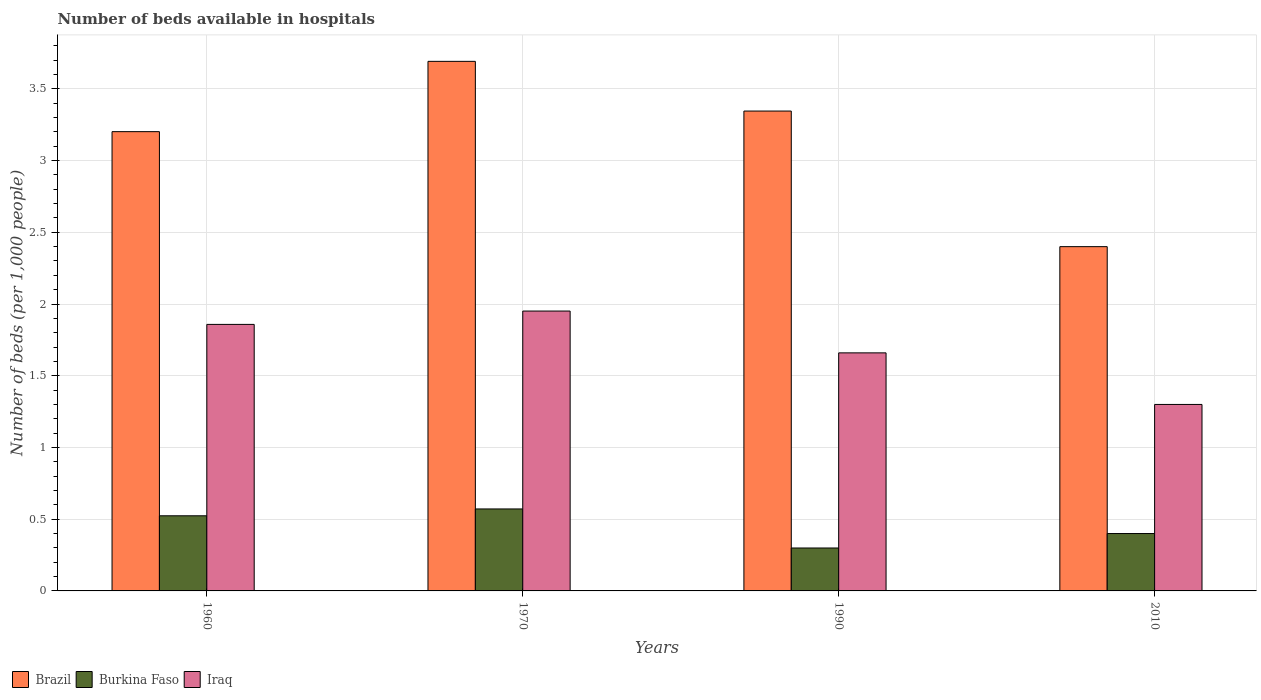How many different coloured bars are there?
Offer a very short reply. 3. How many groups of bars are there?
Provide a short and direct response. 4. Are the number of bars on each tick of the X-axis equal?
Keep it short and to the point. Yes. How many bars are there on the 1st tick from the right?
Your answer should be very brief. 3. Across all years, what is the maximum number of beds in the hospiatls of in Burkina Faso?
Keep it short and to the point. 0.57. In which year was the number of beds in the hospiatls of in Iraq maximum?
Your answer should be compact. 1970. In which year was the number of beds in the hospiatls of in Iraq minimum?
Make the answer very short. 2010. What is the total number of beds in the hospiatls of in Burkina Faso in the graph?
Offer a very short reply. 1.79. What is the difference between the number of beds in the hospiatls of in Brazil in 1970 and that in 1990?
Give a very brief answer. 0.35. What is the difference between the number of beds in the hospiatls of in Iraq in 1960 and the number of beds in the hospiatls of in Burkina Faso in 1990?
Make the answer very short. 1.56. What is the average number of beds in the hospiatls of in Burkina Faso per year?
Offer a terse response. 0.45. In the year 1960, what is the difference between the number of beds in the hospiatls of in Iraq and number of beds in the hospiatls of in Burkina Faso?
Your answer should be compact. 1.33. In how many years, is the number of beds in the hospiatls of in Iraq greater than 2.8?
Offer a terse response. 0. What is the ratio of the number of beds in the hospiatls of in Brazil in 1970 to that in 2010?
Give a very brief answer. 1.54. Is the number of beds in the hospiatls of in Burkina Faso in 1970 less than that in 2010?
Make the answer very short. No. Is the difference between the number of beds in the hospiatls of in Iraq in 1970 and 1990 greater than the difference between the number of beds in the hospiatls of in Burkina Faso in 1970 and 1990?
Your answer should be very brief. Yes. What is the difference between the highest and the second highest number of beds in the hospiatls of in Burkina Faso?
Keep it short and to the point. 0.05. What is the difference between the highest and the lowest number of beds in the hospiatls of in Burkina Faso?
Your answer should be compact. 0.27. In how many years, is the number of beds in the hospiatls of in Iraq greater than the average number of beds in the hospiatls of in Iraq taken over all years?
Keep it short and to the point. 2. Is the sum of the number of beds in the hospiatls of in Burkina Faso in 1960 and 1990 greater than the maximum number of beds in the hospiatls of in Brazil across all years?
Provide a short and direct response. No. What does the 2nd bar from the left in 2010 represents?
Provide a succinct answer. Burkina Faso. What does the 2nd bar from the right in 1970 represents?
Offer a terse response. Burkina Faso. Are all the bars in the graph horizontal?
Ensure brevity in your answer.  No. How many years are there in the graph?
Your answer should be very brief. 4. What is the difference between two consecutive major ticks on the Y-axis?
Your answer should be very brief. 0.5. Are the values on the major ticks of Y-axis written in scientific E-notation?
Your answer should be compact. No. Does the graph contain any zero values?
Your answer should be very brief. No. How are the legend labels stacked?
Provide a succinct answer. Horizontal. What is the title of the graph?
Provide a short and direct response. Number of beds available in hospitals. What is the label or title of the Y-axis?
Provide a short and direct response. Number of beds (per 1,0 people). What is the Number of beds (per 1,000 people) of Brazil in 1960?
Make the answer very short. 3.2. What is the Number of beds (per 1,000 people) of Burkina Faso in 1960?
Keep it short and to the point. 0.52. What is the Number of beds (per 1,000 people) of Iraq in 1960?
Offer a terse response. 1.86. What is the Number of beds (per 1,000 people) of Brazil in 1970?
Your answer should be compact. 3.69. What is the Number of beds (per 1,000 people) in Burkina Faso in 1970?
Your answer should be very brief. 0.57. What is the Number of beds (per 1,000 people) of Iraq in 1970?
Give a very brief answer. 1.95. What is the Number of beds (per 1,000 people) of Brazil in 1990?
Your answer should be very brief. 3.35. What is the Number of beds (per 1,000 people) in Burkina Faso in 1990?
Give a very brief answer. 0.3. What is the Number of beds (per 1,000 people) in Iraq in 1990?
Offer a terse response. 1.66. What is the Number of beds (per 1,000 people) in Iraq in 2010?
Give a very brief answer. 1.3. Across all years, what is the maximum Number of beds (per 1,000 people) of Brazil?
Your answer should be compact. 3.69. Across all years, what is the maximum Number of beds (per 1,000 people) in Burkina Faso?
Your answer should be very brief. 0.57. Across all years, what is the maximum Number of beds (per 1,000 people) of Iraq?
Offer a very short reply. 1.95. Across all years, what is the minimum Number of beds (per 1,000 people) in Brazil?
Your response must be concise. 2.4. Across all years, what is the minimum Number of beds (per 1,000 people) of Burkina Faso?
Make the answer very short. 0.3. What is the total Number of beds (per 1,000 people) in Brazil in the graph?
Keep it short and to the point. 12.64. What is the total Number of beds (per 1,000 people) in Burkina Faso in the graph?
Your answer should be compact. 1.79. What is the total Number of beds (per 1,000 people) of Iraq in the graph?
Your response must be concise. 6.77. What is the difference between the Number of beds (per 1,000 people) in Brazil in 1960 and that in 1970?
Offer a terse response. -0.49. What is the difference between the Number of beds (per 1,000 people) of Burkina Faso in 1960 and that in 1970?
Make the answer very short. -0.05. What is the difference between the Number of beds (per 1,000 people) in Iraq in 1960 and that in 1970?
Provide a succinct answer. -0.09. What is the difference between the Number of beds (per 1,000 people) in Brazil in 1960 and that in 1990?
Offer a terse response. -0.14. What is the difference between the Number of beds (per 1,000 people) in Burkina Faso in 1960 and that in 1990?
Ensure brevity in your answer.  0.22. What is the difference between the Number of beds (per 1,000 people) in Iraq in 1960 and that in 1990?
Provide a short and direct response. 0.2. What is the difference between the Number of beds (per 1,000 people) in Brazil in 1960 and that in 2010?
Your answer should be compact. 0.8. What is the difference between the Number of beds (per 1,000 people) of Burkina Faso in 1960 and that in 2010?
Give a very brief answer. 0.12. What is the difference between the Number of beds (per 1,000 people) of Iraq in 1960 and that in 2010?
Your response must be concise. 0.56. What is the difference between the Number of beds (per 1,000 people) of Brazil in 1970 and that in 1990?
Offer a terse response. 0.35. What is the difference between the Number of beds (per 1,000 people) in Burkina Faso in 1970 and that in 1990?
Your response must be concise. 0.27. What is the difference between the Number of beds (per 1,000 people) in Iraq in 1970 and that in 1990?
Make the answer very short. 0.29. What is the difference between the Number of beds (per 1,000 people) of Brazil in 1970 and that in 2010?
Offer a terse response. 1.29. What is the difference between the Number of beds (per 1,000 people) in Burkina Faso in 1970 and that in 2010?
Make the answer very short. 0.17. What is the difference between the Number of beds (per 1,000 people) in Iraq in 1970 and that in 2010?
Offer a terse response. 0.65. What is the difference between the Number of beds (per 1,000 people) in Brazil in 1990 and that in 2010?
Your answer should be very brief. 0.95. What is the difference between the Number of beds (per 1,000 people) of Burkina Faso in 1990 and that in 2010?
Ensure brevity in your answer.  -0.1. What is the difference between the Number of beds (per 1,000 people) of Iraq in 1990 and that in 2010?
Your answer should be very brief. 0.36. What is the difference between the Number of beds (per 1,000 people) in Brazil in 1960 and the Number of beds (per 1,000 people) in Burkina Faso in 1970?
Give a very brief answer. 2.63. What is the difference between the Number of beds (per 1,000 people) of Brazil in 1960 and the Number of beds (per 1,000 people) of Iraq in 1970?
Provide a succinct answer. 1.25. What is the difference between the Number of beds (per 1,000 people) of Burkina Faso in 1960 and the Number of beds (per 1,000 people) of Iraq in 1970?
Provide a short and direct response. -1.43. What is the difference between the Number of beds (per 1,000 people) in Brazil in 1960 and the Number of beds (per 1,000 people) in Burkina Faso in 1990?
Offer a very short reply. 2.9. What is the difference between the Number of beds (per 1,000 people) in Brazil in 1960 and the Number of beds (per 1,000 people) in Iraq in 1990?
Give a very brief answer. 1.54. What is the difference between the Number of beds (per 1,000 people) of Burkina Faso in 1960 and the Number of beds (per 1,000 people) of Iraq in 1990?
Your response must be concise. -1.14. What is the difference between the Number of beds (per 1,000 people) of Brazil in 1960 and the Number of beds (per 1,000 people) of Burkina Faso in 2010?
Offer a terse response. 2.8. What is the difference between the Number of beds (per 1,000 people) in Brazil in 1960 and the Number of beds (per 1,000 people) in Iraq in 2010?
Make the answer very short. 1.9. What is the difference between the Number of beds (per 1,000 people) in Burkina Faso in 1960 and the Number of beds (per 1,000 people) in Iraq in 2010?
Give a very brief answer. -0.78. What is the difference between the Number of beds (per 1,000 people) in Brazil in 1970 and the Number of beds (per 1,000 people) in Burkina Faso in 1990?
Make the answer very short. 3.39. What is the difference between the Number of beds (per 1,000 people) in Brazil in 1970 and the Number of beds (per 1,000 people) in Iraq in 1990?
Give a very brief answer. 2.03. What is the difference between the Number of beds (per 1,000 people) of Burkina Faso in 1970 and the Number of beds (per 1,000 people) of Iraq in 1990?
Offer a very short reply. -1.09. What is the difference between the Number of beds (per 1,000 people) of Brazil in 1970 and the Number of beds (per 1,000 people) of Burkina Faso in 2010?
Ensure brevity in your answer.  3.29. What is the difference between the Number of beds (per 1,000 people) in Brazil in 1970 and the Number of beds (per 1,000 people) in Iraq in 2010?
Your response must be concise. 2.39. What is the difference between the Number of beds (per 1,000 people) of Burkina Faso in 1970 and the Number of beds (per 1,000 people) of Iraq in 2010?
Your response must be concise. -0.73. What is the difference between the Number of beds (per 1,000 people) in Brazil in 1990 and the Number of beds (per 1,000 people) in Burkina Faso in 2010?
Your answer should be very brief. 2.95. What is the difference between the Number of beds (per 1,000 people) of Brazil in 1990 and the Number of beds (per 1,000 people) of Iraq in 2010?
Ensure brevity in your answer.  2.05. What is the difference between the Number of beds (per 1,000 people) in Burkina Faso in 1990 and the Number of beds (per 1,000 people) in Iraq in 2010?
Make the answer very short. -1. What is the average Number of beds (per 1,000 people) of Brazil per year?
Offer a very short reply. 3.16. What is the average Number of beds (per 1,000 people) of Burkina Faso per year?
Provide a short and direct response. 0.45. What is the average Number of beds (per 1,000 people) in Iraq per year?
Make the answer very short. 1.69. In the year 1960, what is the difference between the Number of beds (per 1,000 people) in Brazil and Number of beds (per 1,000 people) in Burkina Faso?
Your answer should be very brief. 2.68. In the year 1960, what is the difference between the Number of beds (per 1,000 people) of Brazil and Number of beds (per 1,000 people) of Iraq?
Provide a succinct answer. 1.34. In the year 1960, what is the difference between the Number of beds (per 1,000 people) in Burkina Faso and Number of beds (per 1,000 people) in Iraq?
Offer a terse response. -1.33. In the year 1970, what is the difference between the Number of beds (per 1,000 people) of Brazil and Number of beds (per 1,000 people) of Burkina Faso?
Make the answer very short. 3.12. In the year 1970, what is the difference between the Number of beds (per 1,000 people) of Brazil and Number of beds (per 1,000 people) of Iraq?
Make the answer very short. 1.74. In the year 1970, what is the difference between the Number of beds (per 1,000 people) of Burkina Faso and Number of beds (per 1,000 people) of Iraq?
Your answer should be compact. -1.38. In the year 1990, what is the difference between the Number of beds (per 1,000 people) of Brazil and Number of beds (per 1,000 people) of Burkina Faso?
Your answer should be compact. 3.05. In the year 1990, what is the difference between the Number of beds (per 1,000 people) in Brazil and Number of beds (per 1,000 people) in Iraq?
Your answer should be very brief. 1.69. In the year 1990, what is the difference between the Number of beds (per 1,000 people) of Burkina Faso and Number of beds (per 1,000 people) of Iraq?
Offer a terse response. -1.36. What is the ratio of the Number of beds (per 1,000 people) of Brazil in 1960 to that in 1970?
Your response must be concise. 0.87. What is the ratio of the Number of beds (per 1,000 people) of Burkina Faso in 1960 to that in 1970?
Ensure brevity in your answer.  0.92. What is the ratio of the Number of beds (per 1,000 people) of Iraq in 1960 to that in 1970?
Make the answer very short. 0.95. What is the ratio of the Number of beds (per 1,000 people) of Brazil in 1960 to that in 1990?
Keep it short and to the point. 0.96. What is the ratio of the Number of beds (per 1,000 people) in Burkina Faso in 1960 to that in 1990?
Offer a very short reply. 1.75. What is the ratio of the Number of beds (per 1,000 people) of Iraq in 1960 to that in 1990?
Ensure brevity in your answer.  1.12. What is the ratio of the Number of beds (per 1,000 people) of Brazil in 1960 to that in 2010?
Your response must be concise. 1.33. What is the ratio of the Number of beds (per 1,000 people) in Burkina Faso in 1960 to that in 2010?
Offer a terse response. 1.31. What is the ratio of the Number of beds (per 1,000 people) in Iraq in 1960 to that in 2010?
Provide a succinct answer. 1.43. What is the ratio of the Number of beds (per 1,000 people) of Brazil in 1970 to that in 1990?
Your response must be concise. 1.1. What is the ratio of the Number of beds (per 1,000 people) in Burkina Faso in 1970 to that in 1990?
Your response must be concise. 1.91. What is the ratio of the Number of beds (per 1,000 people) in Iraq in 1970 to that in 1990?
Provide a short and direct response. 1.18. What is the ratio of the Number of beds (per 1,000 people) in Brazil in 1970 to that in 2010?
Your answer should be very brief. 1.54. What is the ratio of the Number of beds (per 1,000 people) in Burkina Faso in 1970 to that in 2010?
Your answer should be very brief. 1.43. What is the ratio of the Number of beds (per 1,000 people) of Iraq in 1970 to that in 2010?
Provide a short and direct response. 1.5. What is the ratio of the Number of beds (per 1,000 people) of Brazil in 1990 to that in 2010?
Your answer should be compact. 1.39. What is the ratio of the Number of beds (per 1,000 people) in Burkina Faso in 1990 to that in 2010?
Your response must be concise. 0.75. What is the ratio of the Number of beds (per 1,000 people) of Iraq in 1990 to that in 2010?
Your response must be concise. 1.28. What is the difference between the highest and the second highest Number of beds (per 1,000 people) of Brazil?
Offer a very short reply. 0.35. What is the difference between the highest and the second highest Number of beds (per 1,000 people) of Burkina Faso?
Your answer should be compact. 0.05. What is the difference between the highest and the second highest Number of beds (per 1,000 people) in Iraq?
Your answer should be compact. 0.09. What is the difference between the highest and the lowest Number of beds (per 1,000 people) in Brazil?
Your answer should be compact. 1.29. What is the difference between the highest and the lowest Number of beds (per 1,000 people) of Burkina Faso?
Ensure brevity in your answer.  0.27. What is the difference between the highest and the lowest Number of beds (per 1,000 people) of Iraq?
Offer a very short reply. 0.65. 